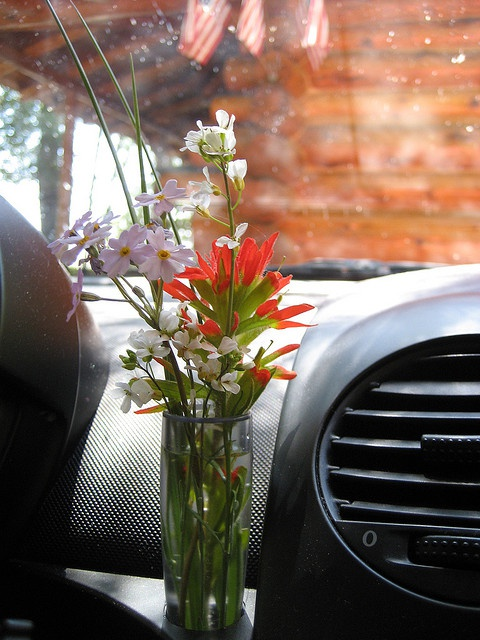Describe the objects in this image and their specific colors. I can see a vase in brown, black, gray, and darkgreen tones in this image. 